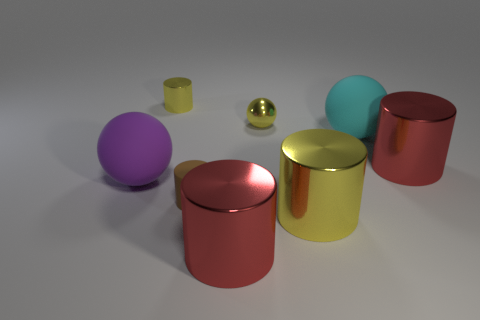Subtract all tiny yellow cylinders. How many cylinders are left? 4 Add 2 big shiny things. How many objects exist? 10 Subtract all red spheres. Subtract all blue cylinders. How many spheres are left? 3 Subtract all cylinders. How many objects are left? 3 Add 4 brown cylinders. How many brown cylinders are left? 5 Add 6 cyan things. How many cyan things exist? 7 Subtract 0 red balls. How many objects are left? 8 Subtract all tiny brown matte balls. Subtract all large purple things. How many objects are left? 7 